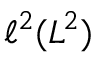<formula> <loc_0><loc_0><loc_500><loc_500>\ell ^ { 2 } ( L ^ { 2 } )</formula> 